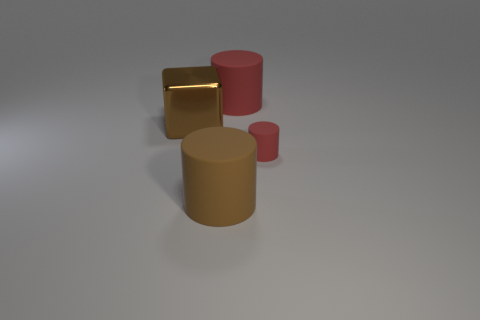Is there a red cylinder that is behind the large rubber thing that is on the right side of the big brown matte cylinder that is in front of the small red rubber cylinder?
Offer a very short reply. No. Do the big rubber cylinder behind the brown rubber cylinder and the small matte cylinder have the same color?
Offer a terse response. Yes. What number of cylinders are large yellow objects or small red things?
Your answer should be compact. 1. What is the shape of the brown thing that is behind the big brown object that is to the right of the brown shiny object?
Your answer should be very brief. Cube. What is the size of the red rubber object behind the large thing on the left side of the large matte cylinder that is in front of the brown metal block?
Offer a terse response. Large. Does the brown matte object have the same size as the brown metal cube?
Ensure brevity in your answer.  Yes. What number of objects are large blue blocks or large red matte cylinders?
Offer a very short reply. 1. There is a matte thing that is right of the large cylinder behind the small red matte cylinder; how big is it?
Offer a terse response. Small. The brown rubber cylinder is what size?
Your answer should be compact. Large. There is a thing that is both behind the big brown rubber cylinder and to the left of the big red rubber thing; what is its shape?
Provide a succinct answer. Cube. 